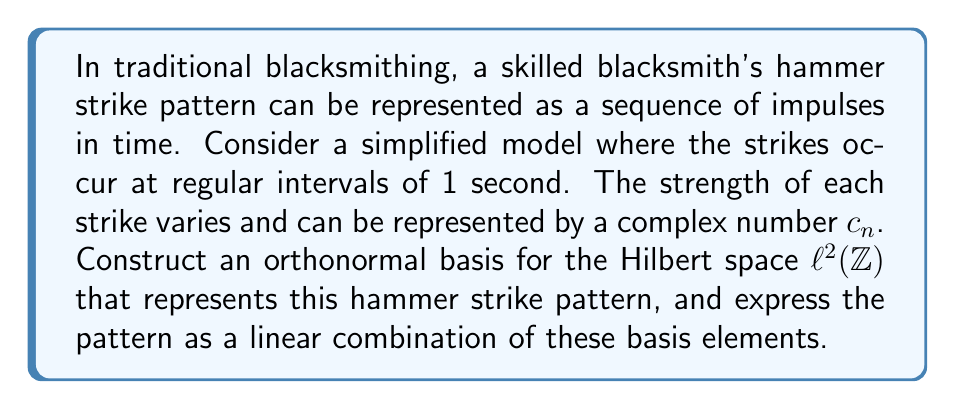Help me with this question. To solve this problem, we'll follow these steps:

1) First, we need to understand that the Hilbert space $\ell^2(\mathbb{Z})$ consists of all square-summable sequences indexed by integers. This is a suitable space for our hammer strike pattern as it allows for an infinite sequence of strikes (both past and future) while ensuring the total energy of the strikes is finite.

2) An orthonormal basis for $\ell^2(\mathbb{Z})$ is given by the standard basis $\{e_k\}_{k \in \mathbb{Z}}$, where:

   $e_k(n) = \begin{cases} 1 & \text{if } n = k \\ 0 & \text{otherwise} \end{cases}$

3) Each $e_k$ represents a single strike at time $k$ seconds, with unit strength.

4) Our hammer strike pattern can be represented as a sequence $x = (c_n)_{n \in \mathbb{Z}}$, where $c_n$ is the complex amplitude of the strike at time $n$ seconds.

5) We can express $x$ as a linear combination of the basis elements:

   $x = \sum_{k \in \mathbb{Z}} c_k e_k$

6) This representation is unique due to the properties of the Hilbert space and the orthonormal basis.

7) The coefficients $c_k$ are given by the inner product of $x$ with each basis element:

   $c_k = \langle x, e_k \rangle = \sum_{n \in \mathbb{Z}} x(n) \overline{e_k(n)} = x(k)$

This representation allows us to analyze the hammer strike pattern in terms of individual strikes, their timing, and their strength. It also enables the application of various Hilbert space techniques for further analysis of the blacksmithing process.
Answer: The orthonormal basis for the Hilbert space representation of the hammer strike pattern is $\{e_k\}_{k \in \mathbb{Z}}$, where $e_k(n) = \delta_{kn}$ (the Kronecker delta). The hammer strike pattern $x = (c_n)_{n \in \mathbb{Z}}$ can be expressed as:

$$x = \sum_{k \in \mathbb{Z}} c_k e_k$$

where $c_k$ represents the strength of the strike at time $k$ seconds. 